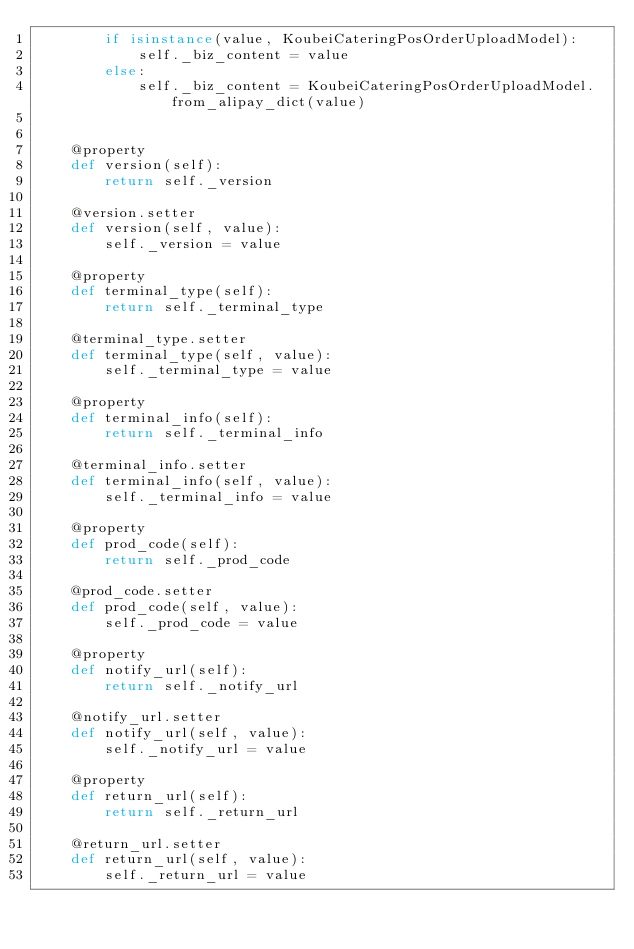<code> <loc_0><loc_0><loc_500><loc_500><_Python_>        if isinstance(value, KoubeiCateringPosOrderUploadModel):
            self._biz_content = value
        else:
            self._biz_content = KoubeiCateringPosOrderUploadModel.from_alipay_dict(value)


    @property
    def version(self):
        return self._version

    @version.setter
    def version(self, value):
        self._version = value

    @property
    def terminal_type(self):
        return self._terminal_type

    @terminal_type.setter
    def terminal_type(self, value):
        self._terminal_type = value

    @property
    def terminal_info(self):
        return self._terminal_info

    @terminal_info.setter
    def terminal_info(self, value):
        self._terminal_info = value

    @property
    def prod_code(self):
        return self._prod_code

    @prod_code.setter
    def prod_code(self, value):
        self._prod_code = value

    @property
    def notify_url(self):
        return self._notify_url

    @notify_url.setter
    def notify_url(self, value):
        self._notify_url = value

    @property
    def return_url(self):
        return self._return_url

    @return_url.setter
    def return_url(self, value):
        self._return_url = value
</code> 